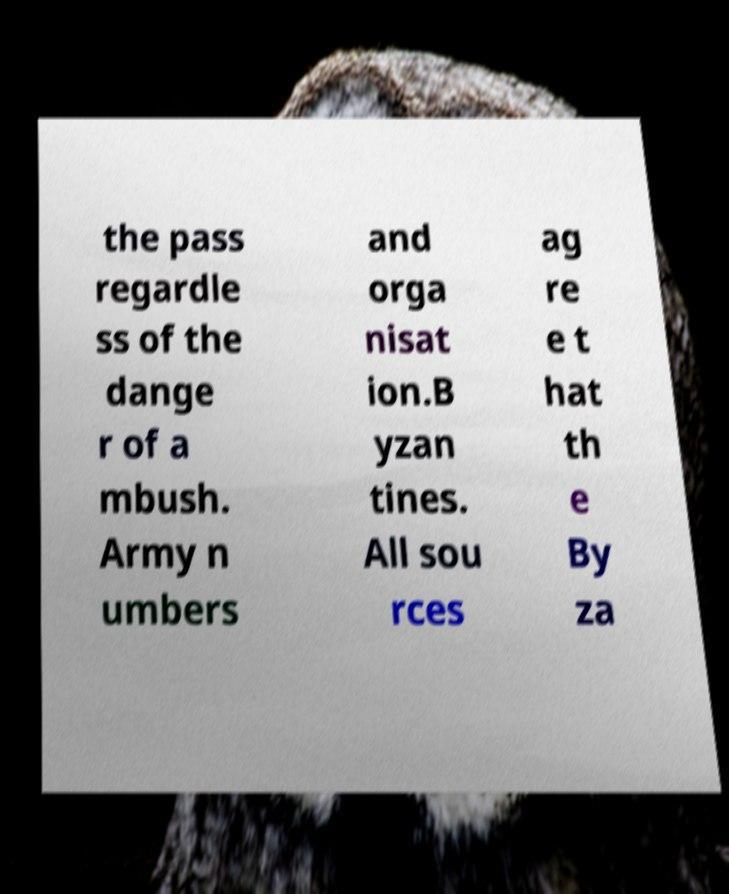I need the written content from this picture converted into text. Can you do that? the pass regardle ss of the dange r of a mbush. Army n umbers and orga nisat ion.B yzan tines. All sou rces ag re e t hat th e By za 